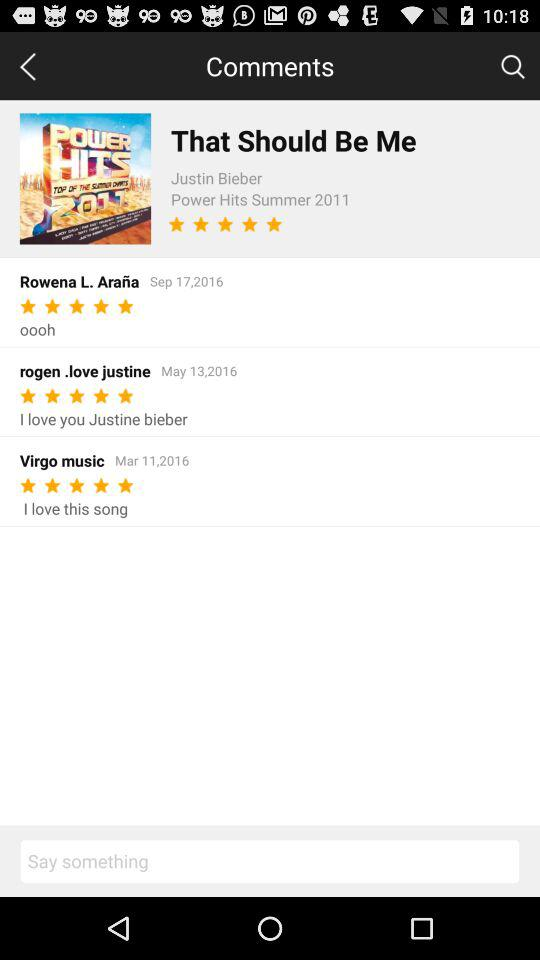Who is the singer of "That Should Be Me"? The singer of "That Should Be Me" is Justin Bieber. 